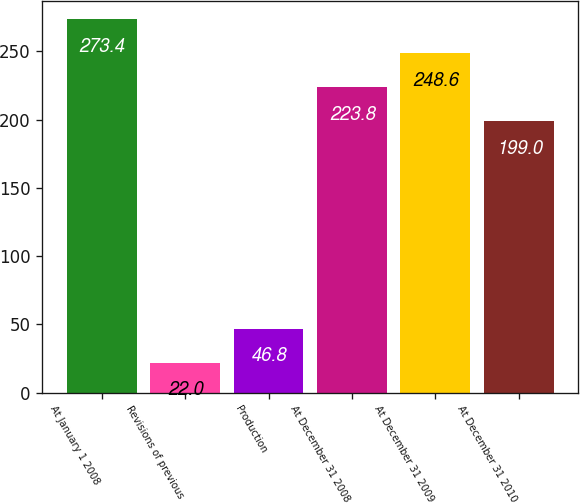<chart> <loc_0><loc_0><loc_500><loc_500><bar_chart><fcel>At January 1 2008<fcel>Revisions of previous<fcel>Production<fcel>At December 31 2008<fcel>At December 31 2009<fcel>At December 31 2010<nl><fcel>273.4<fcel>22<fcel>46.8<fcel>223.8<fcel>248.6<fcel>199<nl></chart> 